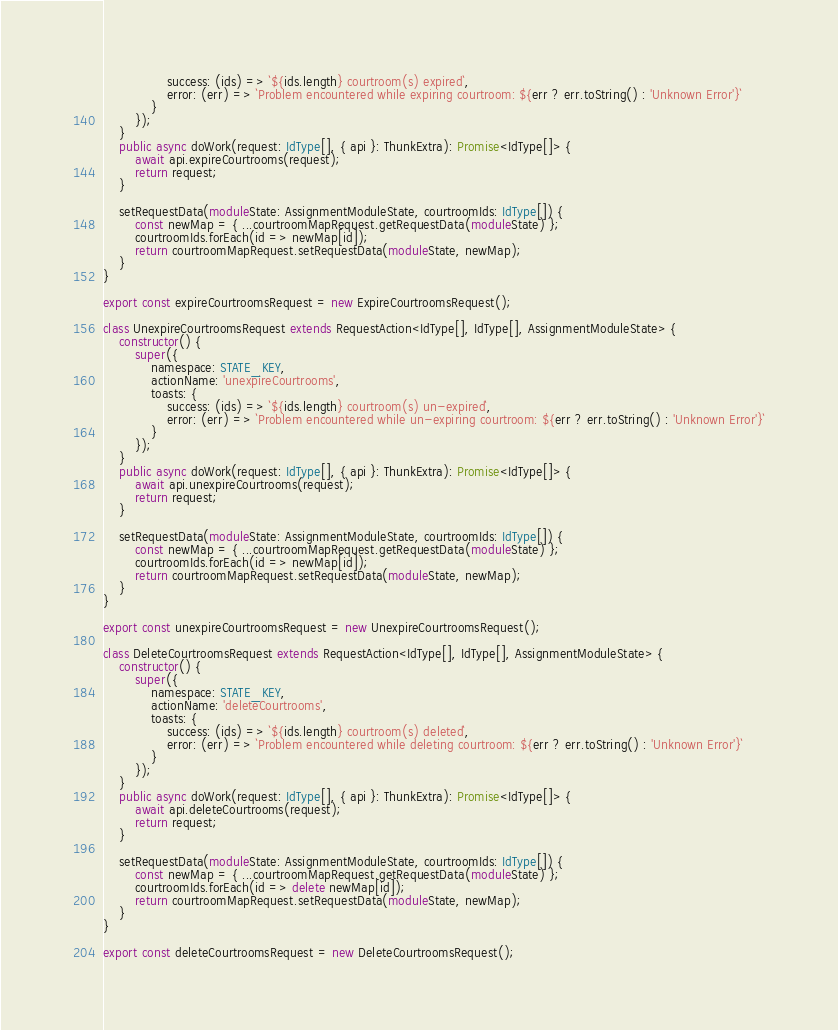Convert code to text. <code><loc_0><loc_0><loc_500><loc_500><_TypeScript_>                success: (ids) => `${ids.length} courtroom(s) expired`,
                error: (err) => `Problem encountered while expiring courtroom: ${err ? err.toString() : 'Unknown Error'}`
            }
        });
    }
    public async doWork(request: IdType[], { api }: ThunkExtra): Promise<IdType[]> {
        await api.expireCourtrooms(request);
        return request;
    }

    setRequestData(moduleState: AssignmentModuleState, courtroomIds: IdType[]) {
        const newMap = { ...courtroomMapRequest.getRequestData(moduleState) };
        courtroomIds.forEach(id => newMap[id]);
        return courtroomMapRequest.setRequestData(moduleState, newMap);
    }
}

export const expireCourtroomsRequest = new ExpireCourtroomsRequest();

class UnexpireCourtroomsRequest extends RequestAction<IdType[], IdType[], AssignmentModuleState> {
    constructor() {
        super({
            namespace: STATE_KEY,
            actionName: 'unexpireCourtrooms',
            toasts: {
                success: (ids) => `${ids.length} courtroom(s) un-expired`,
                error: (err) => `Problem encountered while un-expiring courtroom: ${err ? err.toString() : 'Unknown Error'}`
            }
        });
    }
    public async doWork(request: IdType[], { api }: ThunkExtra): Promise<IdType[]> {
        await api.unexpireCourtrooms(request);
        return request;
    }

    setRequestData(moduleState: AssignmentModuleState, courtroomIds: IdType[]) {
        const newMap = { ...courtroomMapRequest.getRequestData(moduleState) };
        courtroomIds.forEach(id => newMap[id]);
        return courtroomMapRequest.setRequestData(moduleState, newMap);
    }
}

export const unexpireCourtroomsRequest = new UnexpireCourtroomsRequest();

class DeleteCourtroomsRequest extends RequestAction<IdType[], IdType[], AssignmentModuleState> {
    constructor() {
        super({
            namespace: STATE_KEY,
            actionName: 'deleteCourtrooms',
            toasts: {
                success: (ids) => `${ids.length} courtroom(s) deleted`,
                error: (err) => `Problem encountered while deleting courtroom: ${err ? err.toString() : 'Unknown Error'}`
            }
        });
    }
    public async doWork(request: IdType[], { api }: ThunkExtra): Promise<IdType[]> {
        await api.deleteCourtrooms(request);
        return request;
    }

    setRequestData(moduleState: AssignmentModuleState, courtroomIds: IdType[]) {
        const newMap = { ...courtroomMapRequest.getRequestData(moduleState) };
        courtroomIds.forEach(id => delete newMap[id]);
        return courtroomMapRequest.setRequestData(moduleState, newMap);
    }
}

export const deleteCourtroomsRequest = new DeleteCourtroomsRequest();
</code> 